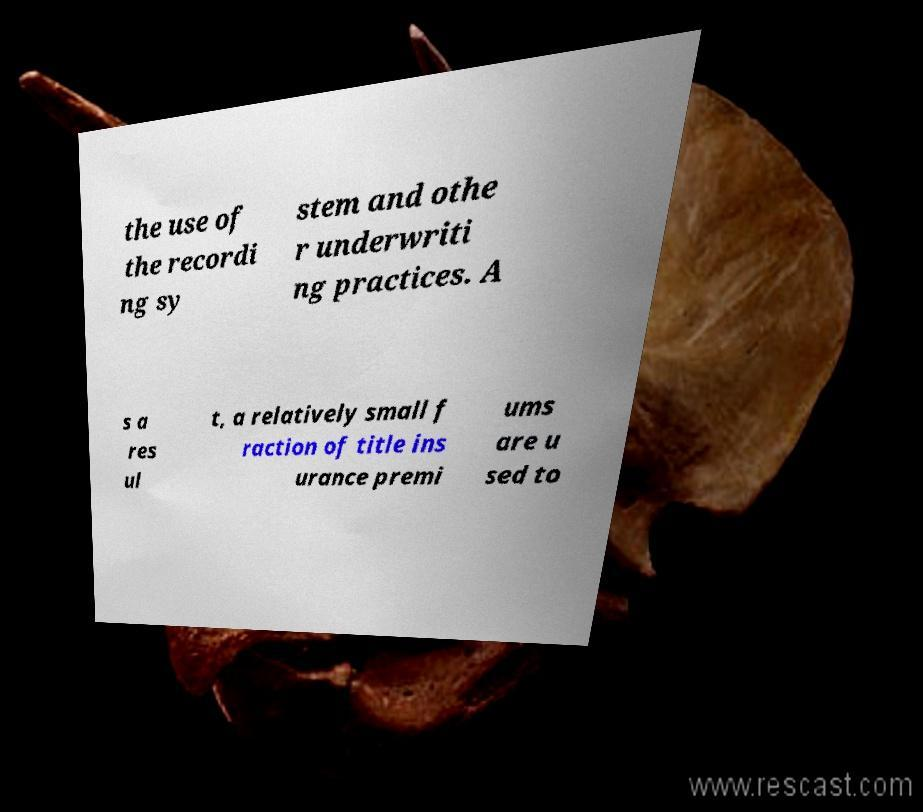Please identify and transcribe the text found in this image. the use of the recordi ng sy stem and othe r underwriti ng practices. A s a res ul t, a relatively small f raction of title ins urance premi ums are u sed to 